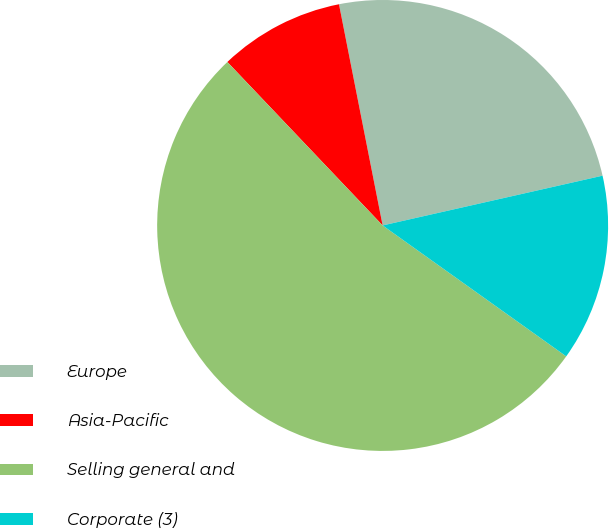<chart> <loc_0><loc_0><loc_500><loc_500><pie_chart><fcel>Europe<fcel>Asia-Pacific<fcel>Selling general and<fcel>Corporate (3)<nl><fcel>24.56%<fcel>8.99%<fcel>53.05%<fcel>13.4%<nl></chart> 